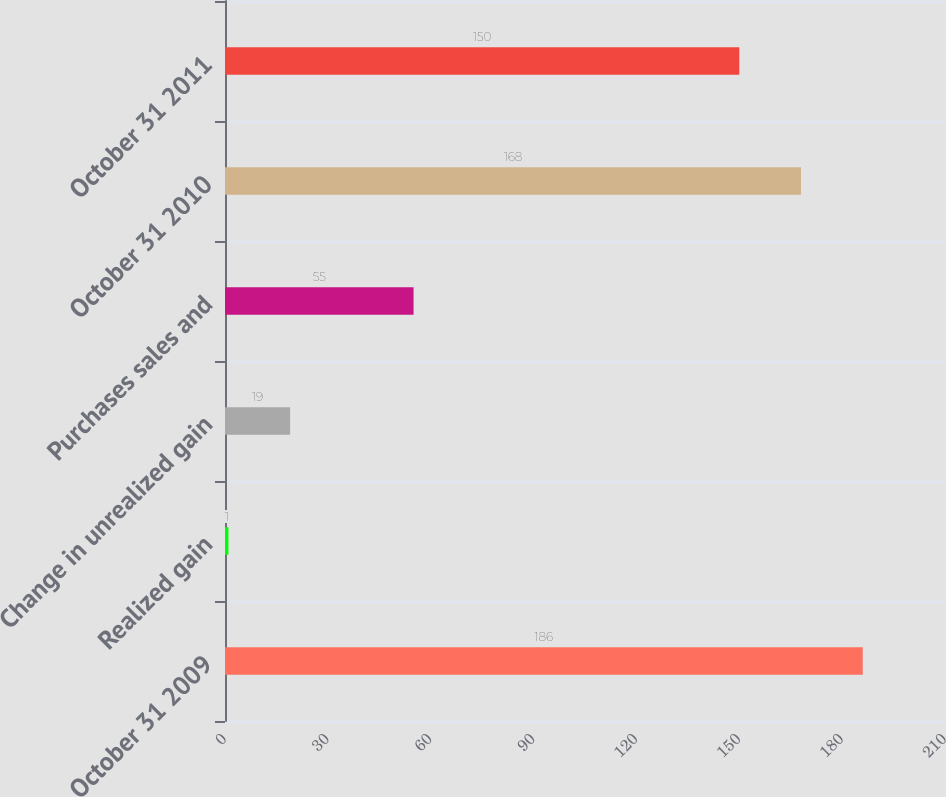Convert chart. <chart><loc_0><loc_0><loc_500><loc_500><bar_chart><fcel>October 31 2009<fcel>Realized gain<fcel>Change in unrealized gain<fcel>Purchases sales and<fcel>October 31 2010<fcel>October 31 2011<nl><fcel>186<fcel>1<fcel>19<fcel>55<fcel>168<fcel>150<nl></chart> 